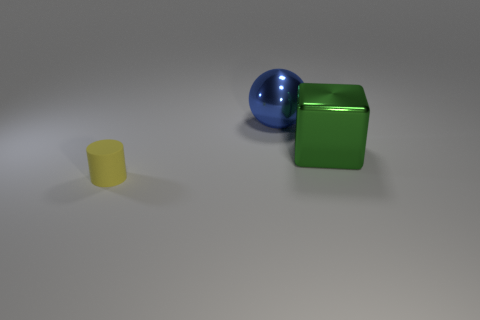Add 1 big yellow shiny blocks. How many objects exist? 4 Subtract all cubes. How many objects are left? 2 Add 1 small yellow objects. How many small yellow objects exist? 2 Subtract 0 brown blocks. How many objects are left? 3 Subtract all cyan matte cylinders. Subtract all green metal things. How many objects are left? 2 Add 3 tiny matte cylinders. How many tiny matte cylinders are left? 4 